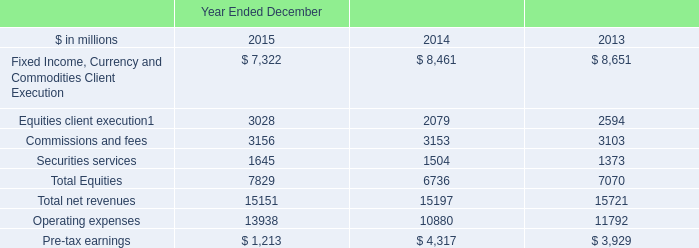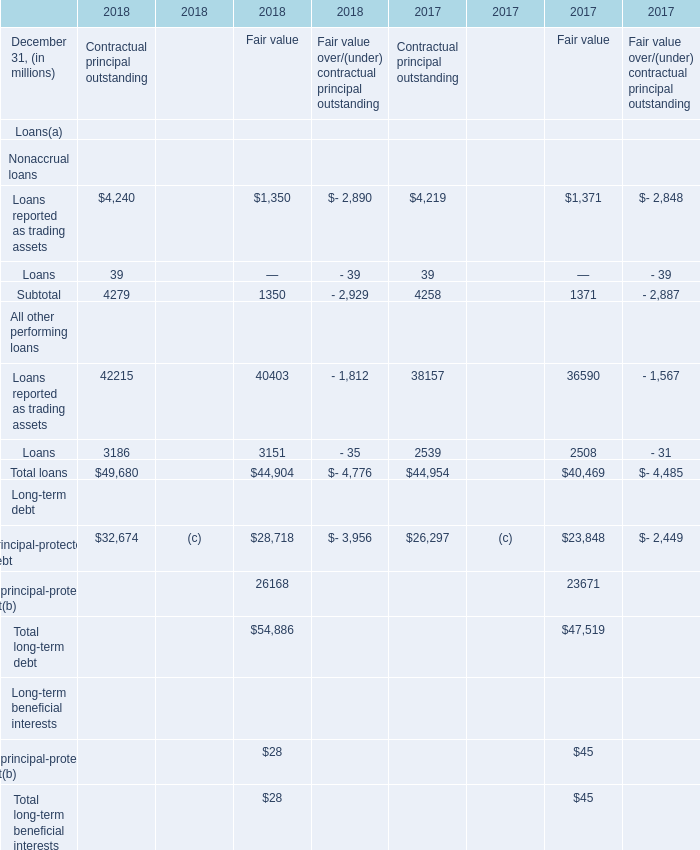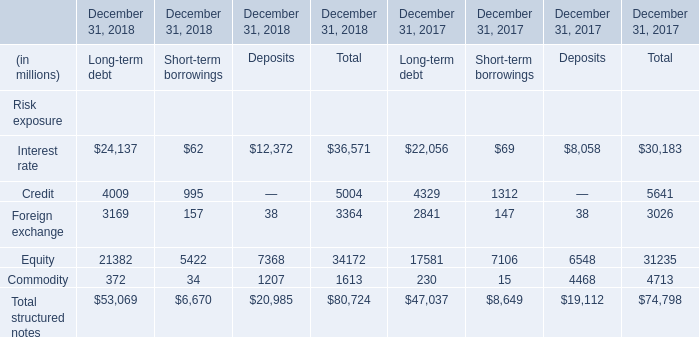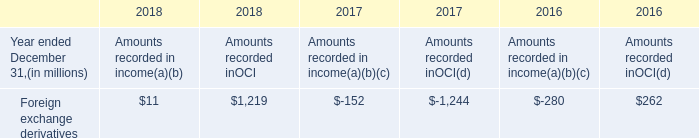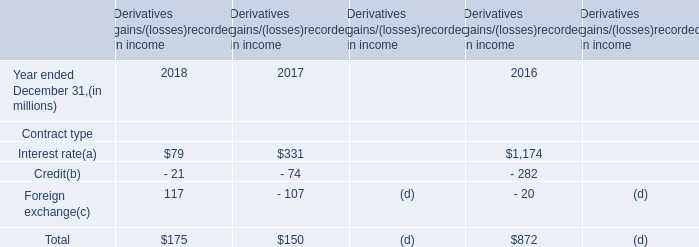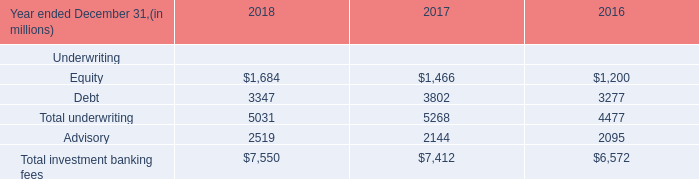What will Principal-protected debt for Fair value be like in 2019 if it develops with the same increasing rate as current? (in million) 
Computations: (28718 * (1 + ((28718 - 23848) / 23848)))
Answer: 34582.50268. 